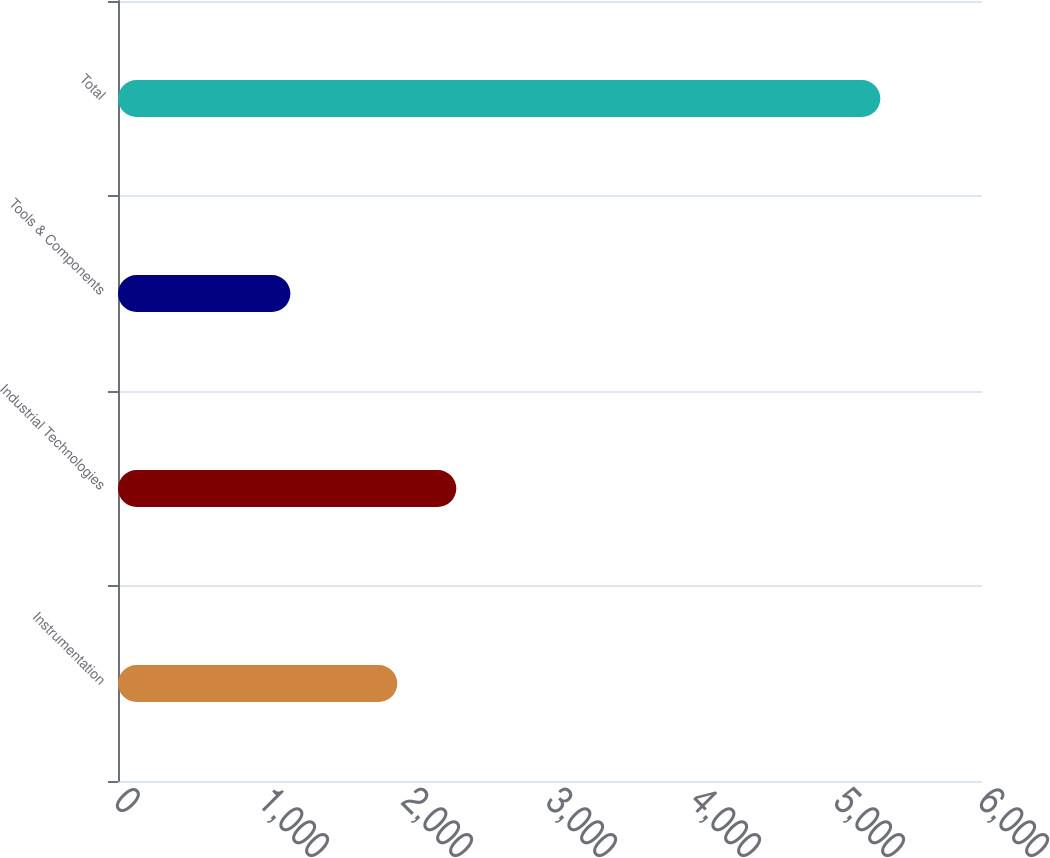<chart> <loc_0><loc_0><loc_500><loc_500><bar_chart><fcel>Instrumentation<fcel>Industrial Technologies<fcel>Tools & Components<fcel>Total<nl><fcel>1939.7<fcel>2349.37<fcel>1197.2<fcel>5293.9<nl></chart> 